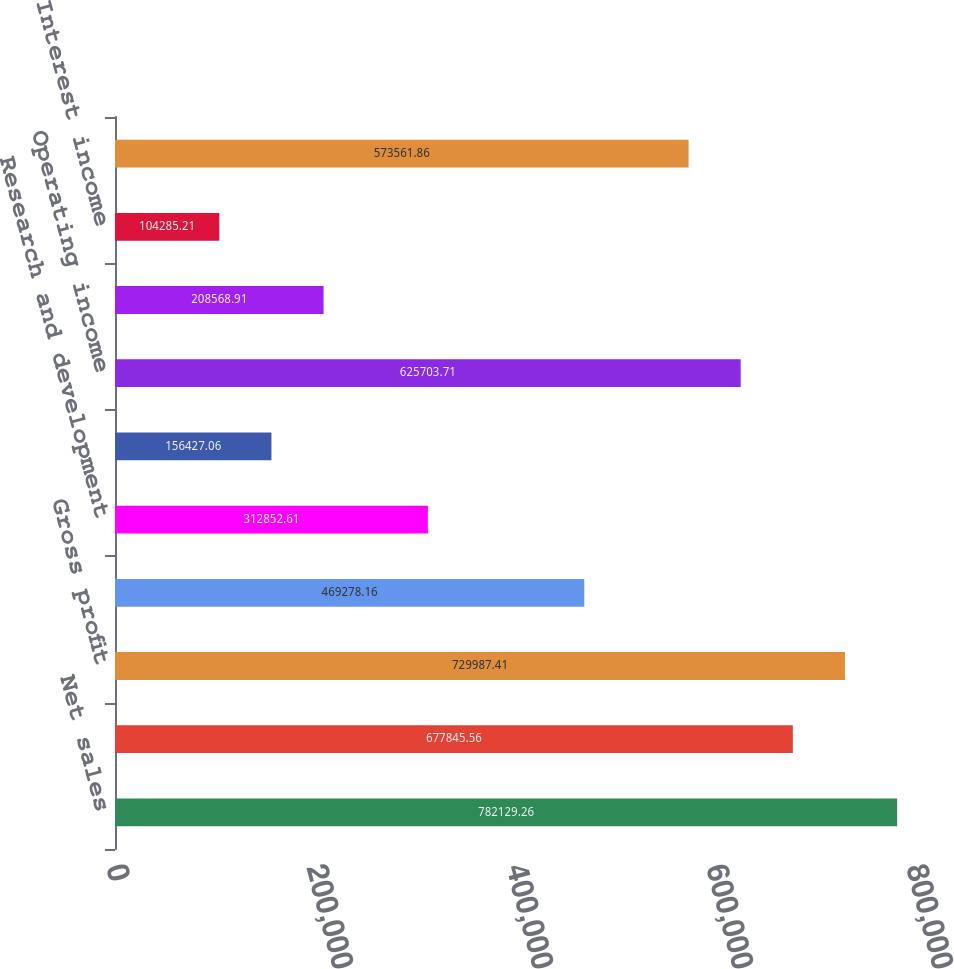<chart> <loc_0><loc_0><loc_500><loc_500><bar_chart><fcel>Net sales<fcel>Cost of sales<fcel>Gross profit<fcel>Selling and administrative<fcel>Research and development<fcel>Purchased intangibles<fcel>Operating income<fcel>Interest expense<fcel>Interest income<fcel>Income from operations before<nl><fcel>782129<fcel>677846<fcel>729987<fcel>469278<fcel>312853<fcel>156427<fcel>625704<fcel>208569<fcel>104285<fcel>573562<nl></chart> 